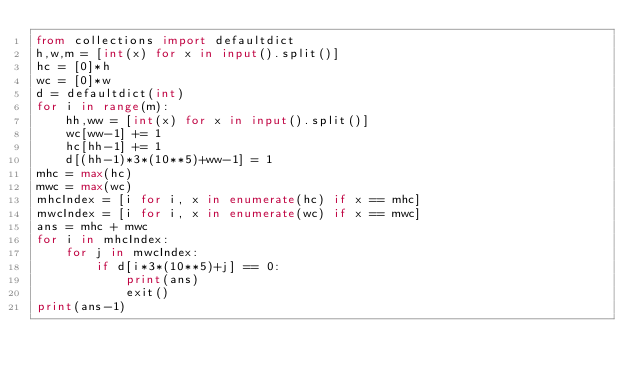<code> <loc_0><loc_0><loc_500><loc_500><_Python_>from collections import defaultdict
h,w,m = [int(x) for x in input().split()]
hc = [0]*h
wc = [0]*w
d = defaultdict(int)
for i in range(m):
    hh,ww = [int(x) for x in input().split()]
    wc[ww-1] += 1
    hc[hh-1] += 1
    d[(hh-1)*3*(10**5)+ww-1] = 1
mhc = max(hc)
mwc = max(wc)
mhcIndex = [i for i, x in enumerate(hc) if x == mhc]
mwcIndex = [i for i, x in enumerate(wc) if x == mwc]
ans = mhc + mwc
for i in mhcIndex:
    for j in mwcIndex:
        if d[i*3*(10**5)+j] == 0:
            print(ans)
            exit()
print(ans-1)</code> 